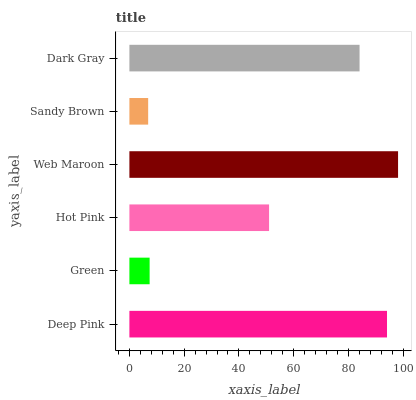Is Sandy Brown the minimum?
Answer yes or no. Yes. Is Web Maroon the maximum?
Answer yes or no. Yes. Is Green the minimum?
Answer yes or no. No. Is Green the maximum?
Answer yes or no. No. Is Deep Pink greater than Green?
Answer yes or no. Yes. Is Green less than Deep Pink?
Answer yes or no. Yes. Is Green greater than Deep Pink?
Answer yes or no. No. Is Deep Pink less than Green?
Answer yes or no. No. Is Dark Gray the high median?
Answer yes or no. Yes. Is Hot Pink the low median?
Answer yes or no. Yes. Is Web Maroon the high median?
Answer yes or no. No. Is Web Maroon the low median?
Answer yes or no. No. 